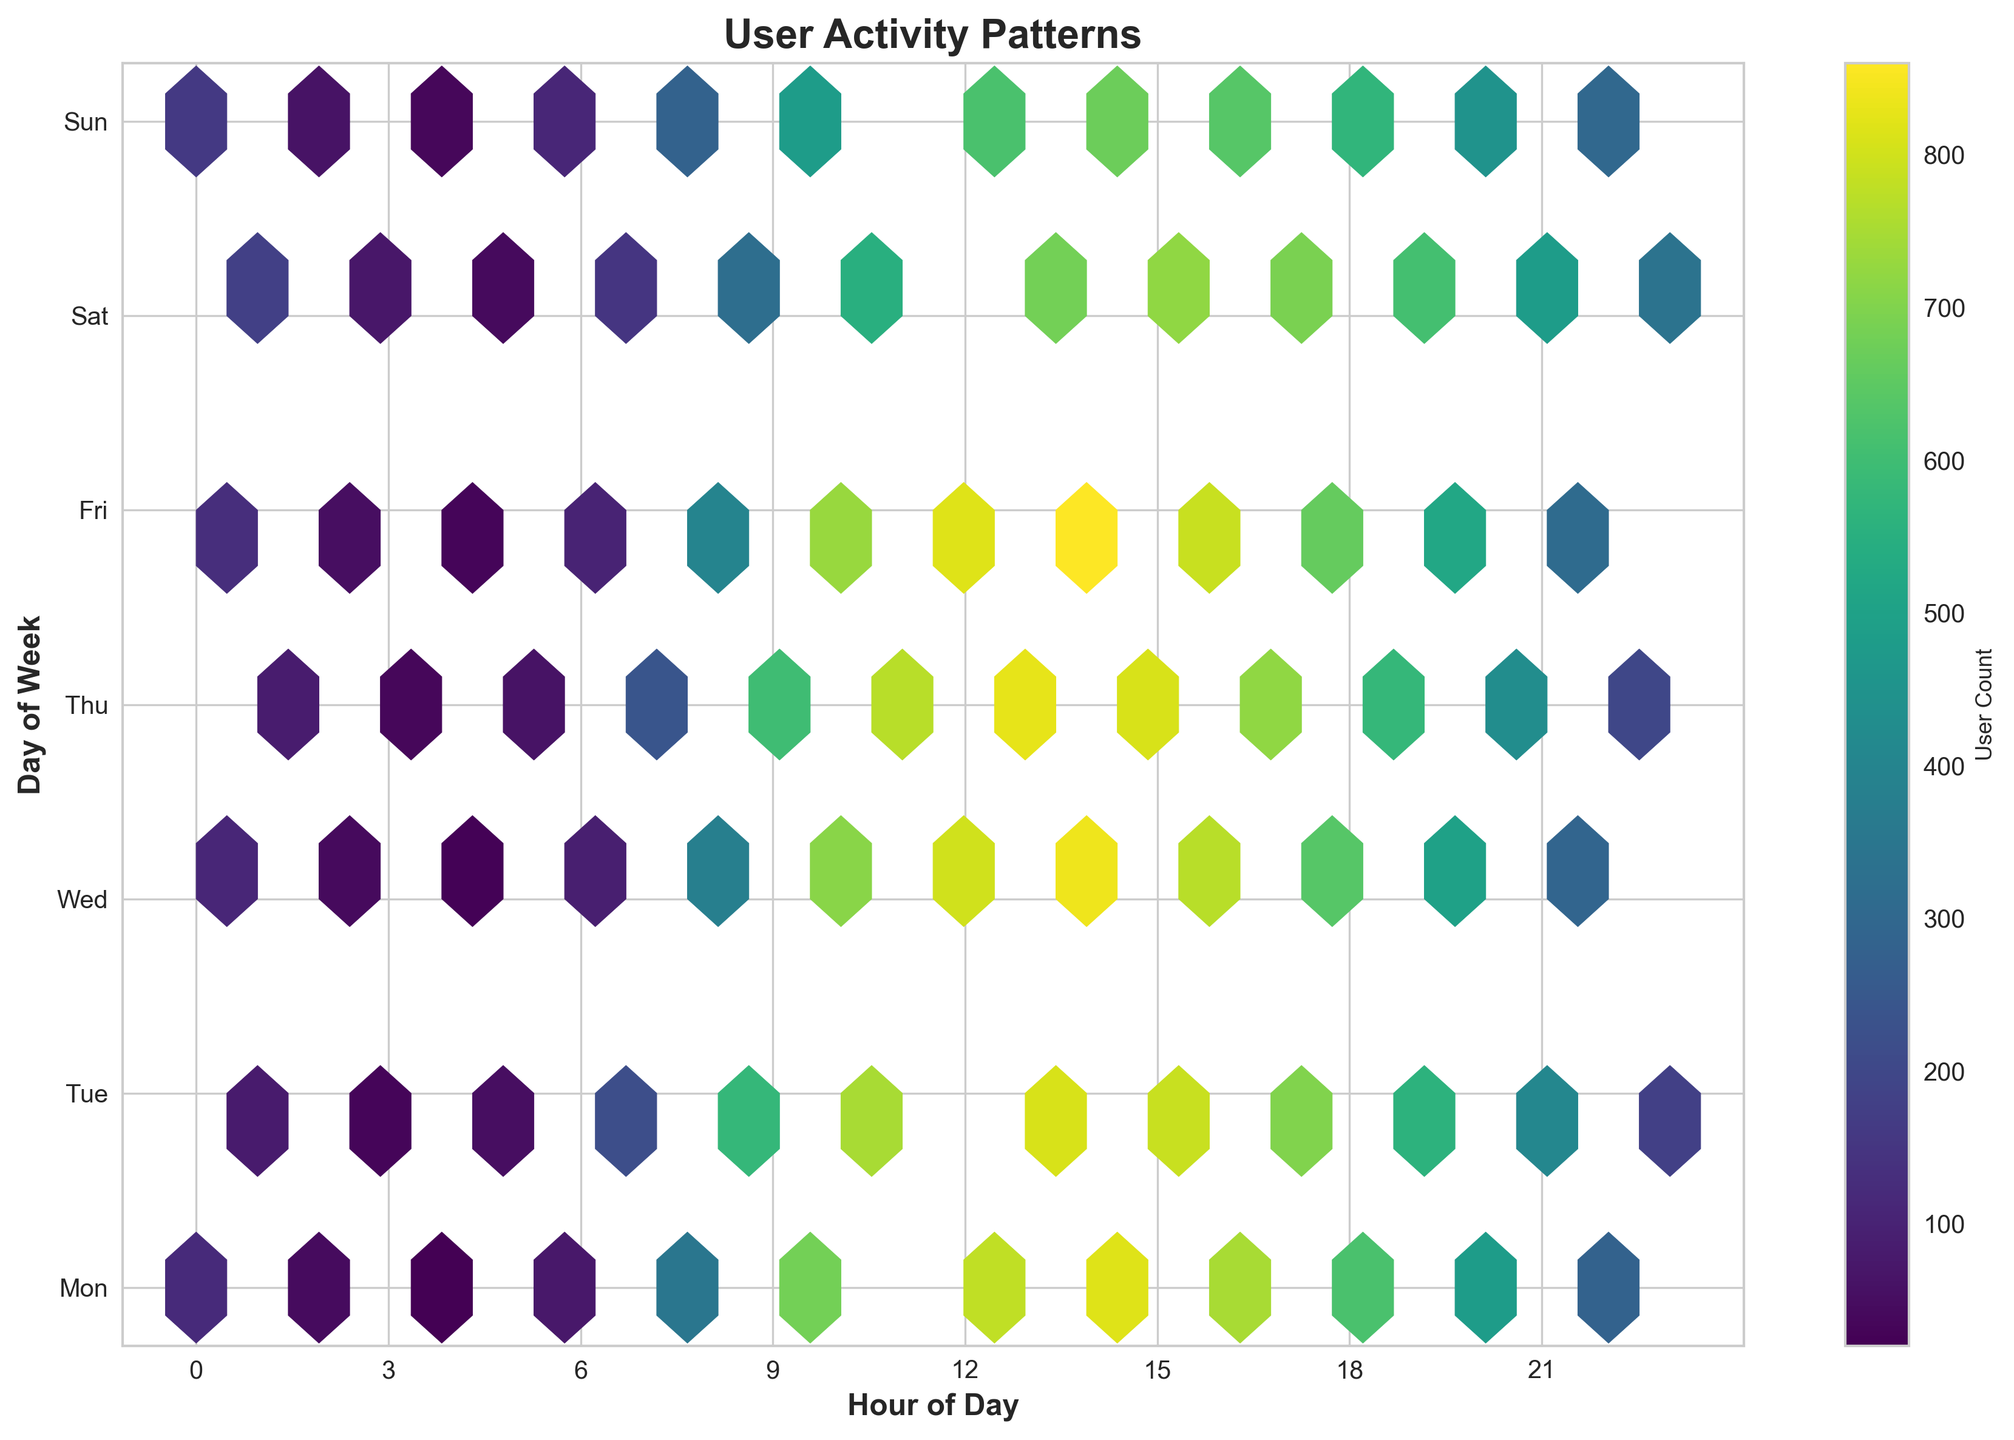What's the title of the figure? The title is usually displayed at the top of the figure. In this case, it reads 'User Activity Patterns'.
Answer: User Activity Patterns What does the x-axis represent? The x-axis labels reveal that it represents the 'Hour of Day', ranging from 0 to 24 hours.
Answer: Hour of Day What does the y-axis represent? The y-axis labels indicate it represents the 'Day of Week', with days mapped as Mon, Tue, Wed, Thu, Fri, Sat, Sun.
Answer: Day of Week Which day shows the highest user activity around 14:00? By examining the plot at the hour mark of 14:00, each day's hexagons show varied intensities. The brightest, most intense hexagon, indicating highest activity, is on Friday.
Answer: Friday What color represents the highest user count, and what color represents the lowest? The color bar shows the gradient from low to high user count. The highest user count is depicted in yellow, and the lowest in dark blue.
Answer: Yellow, Dark Blue Which hours show the lowest user activity on Sunday? By looking at the Sunday row across the hours, the darkest hexagons are around 2:00 and 4:00.
Answer: 2:00 and 4:00 How does user activity at 10:00 on Tuesday compare to 10:00 on Thursday? Comparing the brightness of hexagons at the 10:00 mark for both days, Tuesday shows slightly less activity than Thursday.
Answer: Less on Tuesday On which day and hour is the highest user activity observed? The brightest hexagon in the plot is at the intersection of 14:00 on Friday.
Answer: 14:00 on Friday How does user activity vary from Monday to Wednesday at 8:00? Observing the plot at the 8:00 mark, user activity increases from Monday (350), to Wednesday (380).
Answer: Increases Is there any hour where the user activity consistently decreases from Monday to Sunday? Looking across each hour from Monday to Sunday, no hour shows a consistent decrease in user activity across all days.
Answer: No 